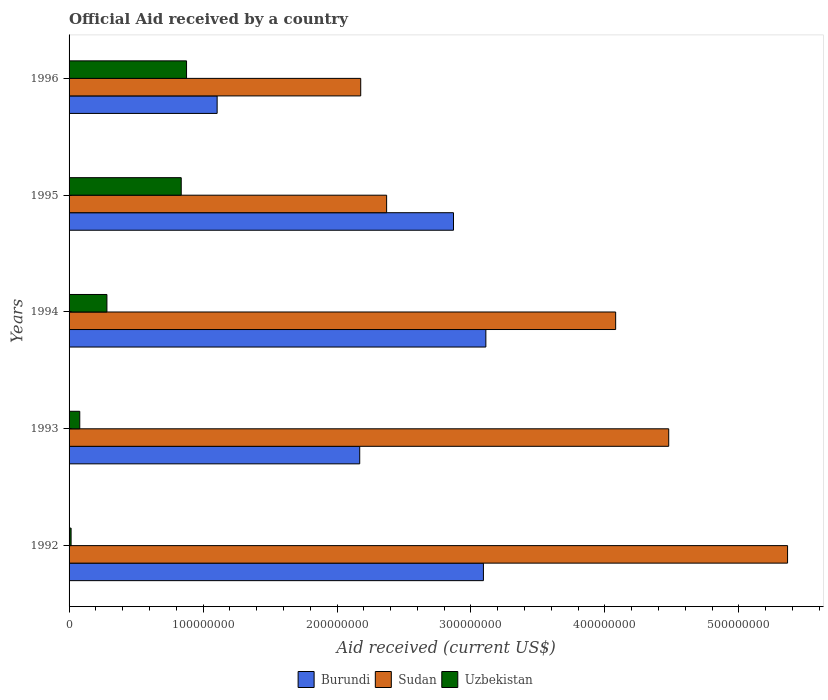How many groups of bars are there?
Offer a terse response. 5. Are the number of bars on each tick of the Y-axis equal?
Offer a very short reply. Yes. How many bars are there on the 4th tick from the top?
Ensure brevity in your answer.  3. What is the label of the 3rd group of bars from the top?
Your answer should be very brief. 1994. What is the net official aid received in Sudan in 1992?
Offer a terse response. 5.36e+08. Across all years, what is the maximum net official aid received in Burundi?
Provide a succinct answer. 3.11e+08. Across all years, what is the minimum net official aid received in Burundi?
Ensure brevity in your answer.  1.11e+08. In which year was the net official aid received in Burundi minimum?
Give a very brief answer. 1996. What is the total net official aid received in Uzbekistan in the graph?
Provide a succinct answer. 2.09e+08. What is the difference between the net official aid received in Burundi in 1992 and that in 1994?
Your answer should be compact. -1.83e+06. What is the difference between the net official aid received in Sudan in 1992 and the net official aid received in Uzbekistan in 1995?
Your answer should be very brief. 4.53e+08. What is the average net official aid received in Burundi per year?
Your response must be concise. 2.47e+08. In the year 1992, what is the difference between the net official aid received in Burundi and net official aid received in Uzbekistan?
Your answer should be compact. 3.08e+08. What is the ratio of the net official aid received in Uzbekistan in 1993 to that in 1995?
Make the answer very short. 0.1. Is the net official aid received in Uzbekistan in 1993 less than that in 1994?
Your response must be concise. Yes. What is the difference between the highest and the second highest net official aid received in Burundi?
Your response must be concise. 1.83e+06. What is the difference between the highest and the lowest net official aid received in Sudan?
Your answer should be very brief. 3.19e+08. What does the 2nd bar from the top in 1992 represents?
Your response must be concise. Sudan. What does the 3rd bar from the bottom in 1993 represents?
Provide a succinct answer. Uzbekistan. Is it the case that in every year, the sum of the net official aid received in Sudan and net official aid received in Uzbekistan is greater than the net official aid received in Burundi?
Ensure brevity in your answer.  Yes. What is the difference between two consecutive major ticks on the X-axis?
Your response must be concise. 1.00e+08. Does the graph contain any zero values?
Offer a terse response. No. Does the graph contain grids?
Give a very brief answer. No. What is the title of the graph?
Offer a terse response. Official Aid received by a country. Does "French Polynesia" appear as one of the legend labels in the graph?
Provide a short and direct response. No. What is the label or title of the X-axis?
Your answer should be very brief. Aid received (current US$). What is the Aid received (current US$) of Burundi in 1992?
Provide a succinct answer. 3.09e+08. What is the Aid received (current US$) in Sudan in 1992?
Offer a terse response. 5.36e+08. What is the Aid received (current US$) in Uzbekistan in 1992?
Your response must be concise. 1.51e+06. What is the Aid received (current US$) in Burundi in 1993?
Make the answer very short. 2.17e+08. What is the Aid received (current US$) of Sudan in 1993?
Your answer should be very brief. 4.48e+08. What is the Aid received (current US$) in Uzbekistan in 1993?
Your answer should be very brief. 7.98e+06. What is the Aid received (current US$) of Burundi in 1994?
Your response must be concise. 3.11e+08. What is the Aid received (current US$) of Sudan in 1994?
Your response must be concise. 4.08e+08. What is the Aid received (current US$) in Uzbekistan in 1994?
Your answer should be compact. 2.82e+07. What is the Aid received (current US$) of Burundi in 1995?
Offer a very short reply. 2.87e+08. What is the Aid received (current US$) in Sudan in 1995?
Make the answer very short. 2.37e+08. What is the Aid received (current US$) of Uzbekistan in 1995?
Your response must be concise. 8.37e+07. What is the Aid received (current US$) of Burundi in 1996?
Provide a succinct answer. 1.11e+08. What is the Aid received (current US$) of Sudan in 1996?
Offer a very short reply. 2.18e+08. What is the Aid received (current US$) in Uzbekistan in 1996?
Your answer should be very brief. 8.77e+07. Across all years, what is the maximum Aid received (current US$) of Burundi?
Your response must be concise. 3.11e+08. Across all years, what is the maximum Aid received (current US$) of Sudan?
Give a very brief answer. 5.36e+08. Across all years, what is the maximum Aid received (current US$) of Uzbekistan?
Ensure brevity in your answer.  8.77e+07. Across all years, what is the minimum Aid received (current US$) of Burundi?
Provide a succinct answer. 1.11e+08. Across all years, what is the minimum Aid received (current US$) in Sudan?
Your answer should be very brief. 2.18e+08. Across all years, what is the minimum Aid received (current US$) in Uzbekistan?
Ensure brevity in your answer.  1.51e+06. What is the total Aid received (current US$) in Burundi in the graph?
Offer a very short reply. 1.23e+09. What is the total Aid received (current US$) in Sudan in the graph?
Offer a terse response. 1.85e+09. What is the total Aid received (current US$) in Uzbekistan in the graph?
Offer a very short reply. 2.09e+08. What is the difference between the Aid received (current US$) in Burundi in 1992 and that in 1993?
Your answer should be compact. 9.23e+07. What is the difference between the Aid received (current US$) of Sudan in 1992 and that in 1993?
Ensure brevity in your answer.  8.87e+07. What is the difference between the Aid received (current US$) in Uzbekistan in 1992 and that in 1993?
Offer a very short reply. -6.47e+06. What is the difference between the Aid received (current US$) in Burundi in 1992 and that in 1994?
Give a very brief answer. -1.83e+06. What is the difference between the Aid received (current US$) in Sudan in 1992 and that in 1994?
Provide a succinct answer. 1.28e+08. What is the difference between the Aid received (current US$) of Uzbekistan in 1992 and that in 1994?
Ensure brevity in your answer.  -2.67e+07. What is the difference between the Aid received (current US$) of Burundi in 1992 and that in 1995?
Offer a very short reply. 2.23e+07. What is the difference between the Aid received (current US$) of Sudan in 1992 and that in 1995?
Provide a succinct answer. 2.99e+08. What is the difference between the Aid received (current US$) of Uzbekistan in 1992 and that in 1995?
Keep it short and to the point. -8.22e+07. What is the difference between the Aid received (current US$) of Burundi in 1992 and that in 1996?
Ensure brevity in your answer.  1.99e+08. What is the difference between the Aid received (current US$) in Sudan in 1992 and that in 1996?
Your answer should be compact. 3.19e+08. What is the difference between the Aid received (current US$) in Uzbekistan in 1992 and that in 1996?
Provide a short and direct response. -8.62e+07. What is the difference between the Aid received (current US$) in Burundi in 1993 and that in 1994?
Your answer should be compact. -9.42e+07. What is the difference between the Aid received (current US$) of Sudan in 1993 and that in 1994?
Your answer should be very brief. 3.96e+07. What is the difference between the Aid received (current US$) in Uzbekistan in 1993 and that in 1994?
Offer a very short reply. -2.03e+07. What is the difference between the Aid received (current US$) in Burundi in 1993 and that in 1995?
Your answer should be compact. -7.00e+07. What is the difference between the Aid received (current US$) in Sudan in 1993 and that in 1995?
Provide a succinct answer. 2.11e+08. What is the difference between the Aid received (current US$) of Uzbekistan in 1993 and that in 1995?
Your answer should be compact. -7.57e+07. What is the difference between the Aid received (current US$) of Burundi in 1993 and that in 1996?
Provide a short and direct response. 1.06e+08. What is the difference between the Aid received (current US$) in Sudan in 1993 and that in 1996?
Give a very brief answer. 2.30e+08. What is the difference between the Aid received (current US$) of Uzbekistan in 1993 and that in 1996?
Ensure brevity in your answer.  -7.97e+07. What is the difference between the Aid received (current US$) in Burundi in 1994 and that in 1995?
Offer a terse response. 2.42e+07. What is the difference between the Aid received (current US$) in Sudan in 1994 and that in 1995?
Ensure brevity in your answer.  1.71e+08. What is the difference between the Aid received (current US$) of Uzbekistan in 1994 and that in 1995?
Keep it short and to the point. -5.55e+07. What is the difference between the Aid received (current US$) in Burundi in 1994 and that in 1996?
Give a very brief answer. 2.01e+08. What is the difference between the Aid received (current US$) of Sudan in 1994 and that in 1996?
Keep it short and to the point. 1.90e+08. What is the difference between the Aid received (current US$) in Uzbekistan in 1994 and that in 1996?
Make the answer very short. -5.94e+07. What is the difference between the Aid received (current US$) of Burundi in 1995 and that in 1996?
Your answer should be very brief. 1.76e+08. What is the difference between the Aid received (current US$) of Sudan in 1995 and that in 1996?
Ensure brevity in your answer.  1.93e+07. What is the difference between the Aid received (current US$) of Uzbekistan in 1995 and that in 1996?
Offer a terse response. -3.97e+06. What is the difference between the Aid received (current US$) in Burundi in 1992 and the Aid received (current US$) in Sudan in 1993?
Your answer should be compact. -1.38e+08. What is the difference between the Aid received (current US$) of Burundi in 1992 and the Aid received (current US$) of Uzbekistan in 1993?
Keep it short and to the point. 3.01e+08. What is the difference between the Aid received (current US$) of Sudan in 1992 and the Aid received (current US$) of Uzbekistan in 1993?
Provide a short and direct response. 5.28e+08. What is the difference between the Aid received (current US$) in Burundi in 1992 and the Aid received (current US$) in Sudan in 1994?
Offer a very short reply. -9.87e+07. What is the difference between the Aid received (current US$) of Burundi in 1992 and the Aid received (current US$) of Uzbekistan in 1994?
Offer a very short reply. 2.81e+08. What is the difference between the Aid received (current US$) in Sudan in 1992 and the Aid received (current US$) in Uzbekistan in 1994?
Your answer should be very brief. 5.08e+08. What is the difference between the Aid received (current US$) in Burundi in 1992 and the Aid received (current US$) in Sudan in 1995?
Keep it short and to the point. 7.22e+07. What is the difference between the Aid received (current US$) in Burundi in 1992 and the Aid received (current US$) in Uzbekistan in 1995?
Offer a very short reply. 2.26e+08. What is the difference between the Aid received (current US$) in Sudan in 1992 and the Aid received (current US$) in Uzbekistan in 1995?
Keep it short and to the point. 4.53e+08. What is the difference between the Aid received (current US$) in Burundi in 1992 and the Aid received (current US$) in Sudan in 1996?
Your answer should be very brief. 9.16e+07. What is the difference between the Aid received (current US$) in Burundi in 1992 and the Aid received (current US$) in Uzbekistan in 1996?
Make the answer very short. 2.22e+08. What is the difference between the Aid received (current US$) in Sudan in 1992 and the Aid received (current US$) in Uzbekistan in 1996?
Offer a terse response. 4.49e+08. What is the difference between the Aid received (current US$) of Burundi in 1993 and the Aid received (current US$) of Sudan in 1994?
Your response must be concise. -1.91e+08. What is the difference between the Aid received (current US$) of Burundi in 1993 and the Aid received (current US$) of Uzbekistan in 1994?
Keep it short and to the point. 1.89e+08. What is the difference between the Aid received (current US$) of Sudan in 1993 and the Aid received (current US$) of Uzbekistan in 1994?
Your answer should be compact. 4.19e+08. What is the difference between the Aid received (current US$) in Burundi in 1993 and the Aid received (current US$) in Sudan in 1995?
Provide a succinct answer. -2.01e+07. What is the difference between the Aid received (current US$) in Burundi in 1993 and the Aid received (current US$) in Uzbekistan in 1995?
Ensure brevity in your answer.  1.33e+08. What is the difference between the Aid received (current US$) in Sudan in 1993 and the Aid received (current US$) in Uzbekistan in 1995?
Provide a short and direct response. 3.64e+08. What is the difference between the Aid received (current US$) of Burundi in 1993 and the Aid received (current US$) of Sudan in 1996?
Provide a short and direct response. -7.50e+05. What is the difference between the Aid received (current US$) in Burundi in 1993 and the Aid received (current US$) in Uzbekistan in 1996?
Offer a very short reply. 1.29e+08. What is the difference between the Aid received (current US$) in Sudan in 1993 and the Aid received (current US$) in Uzbekistan in 1996?
Make the answer very short. 3.60e+08. What is the difference between the Aid received (current US$) in Burundi in 1994 and the Aid received (current US$) in Sudan in 1995?
Offer a terse response. 7.41e+07. What is the difference between the Aid received (current US$) in Burundi in 1994 and the Aid received (current US$) in Uzbekistan in 1995?
Provide a short and direct response. 2.27e+08. What is the difference between the Aid received (current US$) in Sudan in 1994 and the Aid received (current US$) in Uzbekistan in 1995?
Make the answer very short. 3.24e+08. What is the difference between the Aid received (current US$) of Burundi in 1994 and the Aid received (current US$) of Sudan in 1996?
Ensure brevity in your answer.  9.34e+07. What is the difference between the Aid received (current US$) of Burundi in 1994 and the Aid received (current US$) of Uzbekistan in 1996?
Your answer should be compact. 2.23e+08. What is the difference between the Aid received (current US$) in Sudan in 1994 and the Aid received (current US$) in Uzbekistan in 1996?
Ensure brevity in your answer.  3.20e+08. What is the difference between the Aid received (current US$) of Burundi in 1995 and the Aid received (current US$) of Sudan in 1996?
Make the answer very short. 6.92e+07. What is the difference between the Aid received (current US$) of Burundi in 1995 and the Aid received (current US$) of Uzbekistan in 1996?
Ensure brevity in your answer.  1.99e+08. What is the difference between the Aid received (current US$) in Sudan in 1995 and the Aid received (current US$) in Uzbekistan in 1996?
Provide a short and direct response. 1.49e+08. What is the average Aid received (current US$) in Burundi per year?
Provide a succinct answer. 2.47e+08. What is the average Aid received (current US$) in Sudan per year?
Provide a short and direct response. 3.69e+08. What is the average Aid received (current US$) of Uzbekistan per year?
Make the answer very short. 4.18e+07. In the year 1992, what is the difference between the Aid received (current US$) in Burundi and Aid received (current US$) in Sudan?
Your answer should be very brief. -2.27e+08. In the year 1992, what is the difference between the Aid received (current US$) in Burundi and Aid received (current US$) in Uzbekistan?
Offer a terse response. 3.08e+08. In the year 1992, what is the difference between the Aid received (current US$) of Sudan and Aid received (current US$) of Uzbekistan?
Keep it short and to the point. 5.35e+08. In the year 1993, what is the difference between the Aid received (current US$) in Burundi and Aid received (current US$) in Sudan?
Your answer should be very brief. -2.31e+08. In the year 1993, what is the difference between the Aid received (current US$) in Burundi and Aid received (current US$) in Uzbekistan?
Offer a very short reply. 2.09e+08. In the year 1993, what is the difference between the Aid received (current US$) of Sudan and Aid received (current US$) of Uzbekistan?
Make the answer very short. 4.40e+08. In the year 1994, what is the difference between the Aid received (current US$) of Burundi and Aid received (current US$) of Sudan?
Your response must be concise. -9.69e+07. In the year 1994, what is the difference between the Aid received (current US$) in Burundi and Aid received (current US$) in Uzbekistan?
Provide a succinct answer. 2.83e+08. In the year 1994, what is the difference between the Aid received (current US$) of Sudan and Aid received (current US$) of Uzbekistan?
Provide a succinct answer. 3.80e+08. In the year 1995, what is the difference between the Aid received (current US$) of Burundi and Aid received (current US$) of Sudan?
Your response must be concise. 4.99e+07. In the year 1995, what is the difference between the Aid received (current US$) of Burundi and Aid received (current US$) of Uzbekistan?
Your answer should be very brief. 2.03e+08. In the year 1995, what is the difference between the Aid received (current US$) of Sudan and Aid received (current US$) of Uzbekistan?
Ensure brevity in your answer.  1.53e+08. In the year 1996, what is the difference between the Aid received (current US$) of Burundi and Aid received (current US$) of Sudan?
Your response must be concise. -1.07e+08. In the year 1996, what is the difference between the Aid received (current US$) of Burundi and Aid received (current US$) of Uzbekistan?
Give a very brief answer. 2.28e+07. In the year 1996, what is the difference between the Aid received (current US$) of Sudan and Aid received (current US$) of Uzbekistan?
Ensure brevity in your answer.  1.30e+08. What is the ratio of the Aid received (current US$) in Burundi in 1992 to that in 1993?
Make the answer very short. 1.43. What is the ratio of the Aid received (current US$) in Sudan in 1992 to that in 1993?
Your answer should be very brief. 1.2. What is the ratio of the Aid received (current US$) in Uzbekistan in 1992 to that in 1993?
Give a very brief answer. 0.19. What is the ratio of the Aid received (current US$) of Burundi in 1992 to that in 1994?
Provide a succinct answer. 0.99. What is the ratio of the Aid received (current US$) in Sudan in 1992 to that in 1994?
Give a very brief answer. 1.31. What is the ratio of the Aid received (current US$) of Uzbekistan in 1992 to that in 1994?
Make the answer very short. 0.05. What is the ratio of the Aid received (current US$) of Burundi in 1992 to that in 1995?
Keep it short and to the point. 1.08. What is the ratio of the Aid received (current US$) of Sudan in 1992 to that in 1995?
Your answer should be compact. 2.26. What is the ratio of the Aid received (current US$) in Uzbekistan in 1992 to that in 1995?
Keep it short and to the point. 0.02. What is the ratio of the Aid received (current US$) in Burundi in 1992 to that in 1996?
Provide a succinct answer. 2.8. What is the ratio of the Aid received (current US$) of Sudan in 1992 to that in 1996?
Your answer should be compact. 2.46. What is the ratio of the Aid received (current US$) in Uzbekistan in 1992 to that in 1996?
Offer a terse response. 0.02. What is the ratio of the Aid received (current US$) in Burundi in 1993 to that in 1994?
Your answer should be very brief. 0.7. What is the ratio of the Aid received (current US$) in Sudan in 1993 to that in 1994?
Provide a succinct answer. 1.1. What is the ratio of the Aid received (current US$) in Uzbekistan in 1993 to that in 1994?
Provide a short and direct response. 0.28. What is the ratio of the Aid received (current US$) of Burundi in 1993 to that in 1995?
Ensure brevity in your answer.  0.76. What is the ratio of the Aid received (current US$) of Sudan in 1993 to that in 1995?
Keep it short and to the point. 1.89. What is the ratio of the Aid received (current US$) of Uzbekistan in 1993 to that in 1995?
Offer a very short reply. 0.1. What is the ratio of the Aid received (current US$) of Burundi in 1993 to that in 1996?
Make the answer very short. 1.96. What is the ratio of the Aid received (current US$) of Sudan in 1993 to that in 1996?
Your answer should be compact. 2.06. What is the ratio of the Aid received (current US$) of Uzbekistan in 1993 to that in 1996?
Offer a terse response. 0.09. What is the ratio of the Aid received (current US$) in Burundi in 1994 to that in 1995?
Make the answer very short. 1.08. What is the ratio of the Aid received (current US$) in Sudan in 1994 to that in 1995?
Make the answer very short. 1.72. What is the ratio of the Aid received (current US$) of Uzbekistan in 1994 to that in 1995?
Provide a succinct answer. 0.34. What is the ratio of the Aid received (current US$) in Burundi in 1994 to that in 1996?
Offer a very short reply. 2.81. What is the ratio of the Aid received (current US$) in Sudan in 1994 to that in 1996?
Offer a terse response. 1.87. What is the ratio of the Aid received (current US$) in Uzbekistan in 1994 to that in 1996?
Your response must be concise. 0.32. What is the ratio of the Aid received (current US$) of Burundi in 1995 to that in 1996?
Give a very brief answer. 2.6. What is the ratio of the Aid received (current US$) in Sudan in 1995 to that in 1996?
Give a very brief answer. 1.09. What is the ratio of the Aid received (current US$) in Uzbekistan in 1995 to that in 1996?
Provide a succinct answer. 0.95. What is the difference between the highest and the second highest Aid received (current US$) in Burundi?
Ensure brevity in your answer.  1.83e+06. What is the difference between the highest and the second highest Aid received (current US$) of Sudan?
Offer a very short reply. 8.87e+07. What is the difference between the highest and the second highest Aid received (current US$) in Uzbekistan?
Keep it short and to the point. 3.97e+06. What is the difference between the highest and the lowest Aid received (current US$) in Burundi?
Give a very brief answer. 2.01e+08. What is the difference between the highest and the lowest Aid received (current US$) of Sudan?
Offer a very short reply. 3.19e+08. What is the difference between the highest and the lowest Aid received (current US$) of Uzbekistan?
Provide a short and direct response. 8.62e+07. 